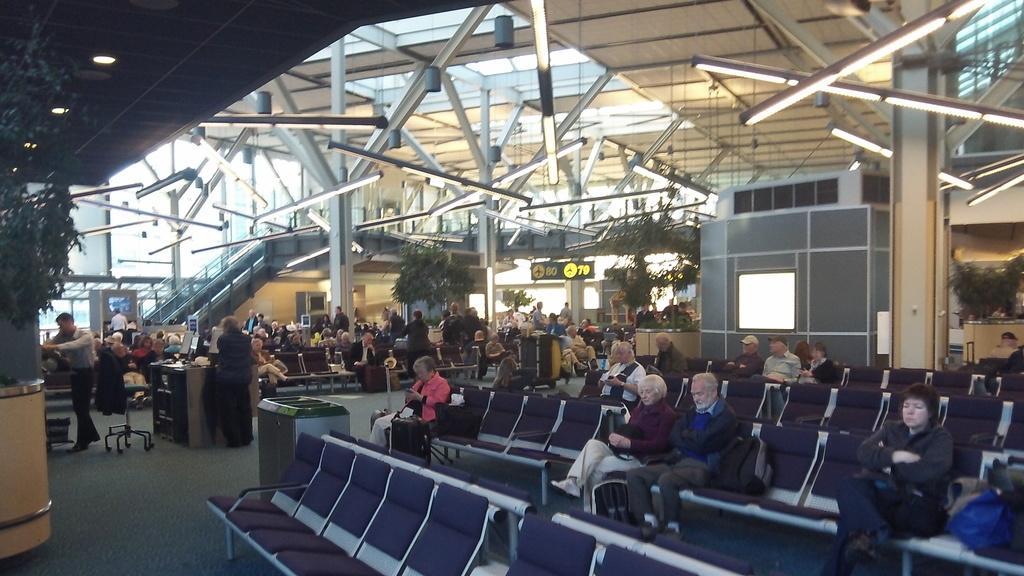In one or two sentences, can you explain what this image depicts? Here, at the right side there are some chairs and there are some people sitting on the chairs, at the left side there are two persons standing, at the top there are some lights and there is a shed. 